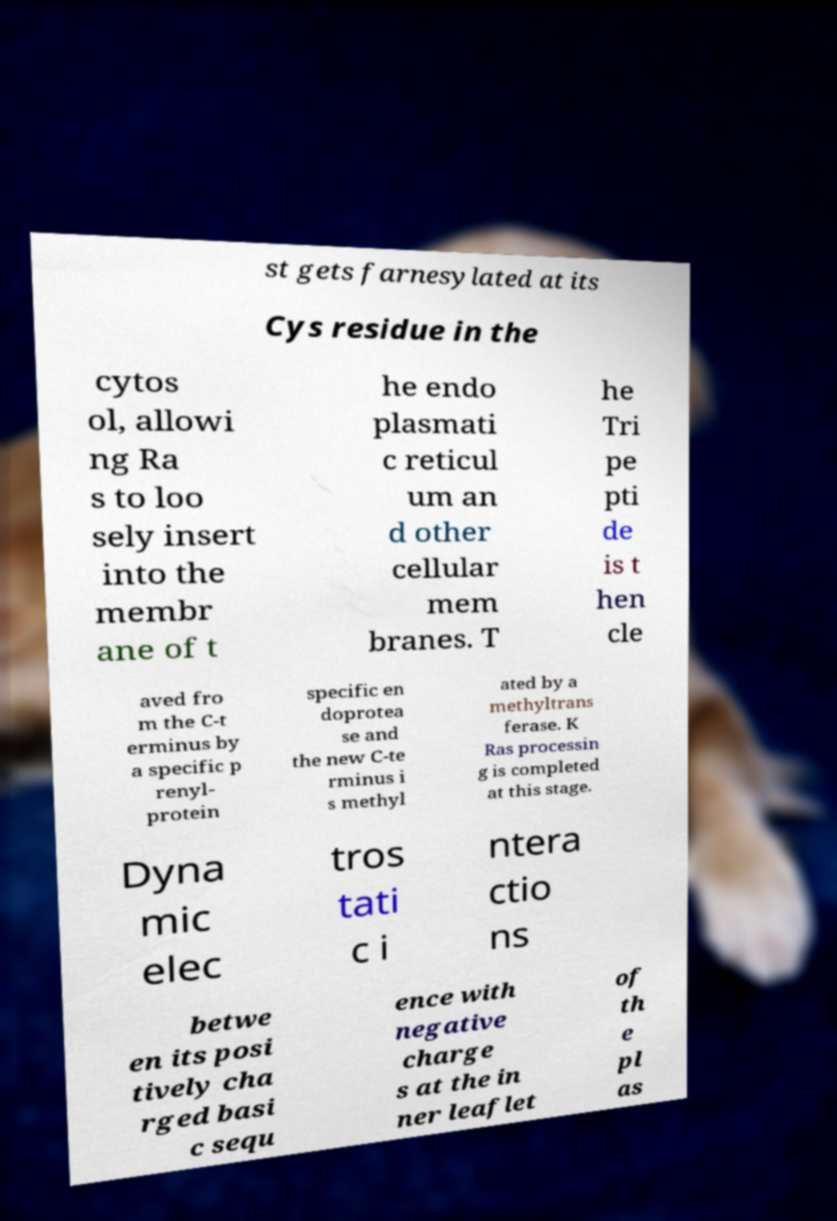Please read and relay the text visible in this image. What does it say? st gets farnesylated at its Cys residue in the cytos ol, allowi ng Ra s to loo sely insert into the membr ane of t he endo plasmati c reticul um an d other cellular mem branes. T he Tri pe pti de is t hen cle aved fro m the C-t erminus by a specific p renyl- protein specific en doprotea se and the new C-te rminus i s methyl ated by a methyltrans ferase. K Ras processin g is completed at this stage. Dyna mic elec tros tati c i ntera ctio ns betwe en its posi tively cha rged basi c sequ ence with negative charge s at the in ner leaflet of th e pl as 